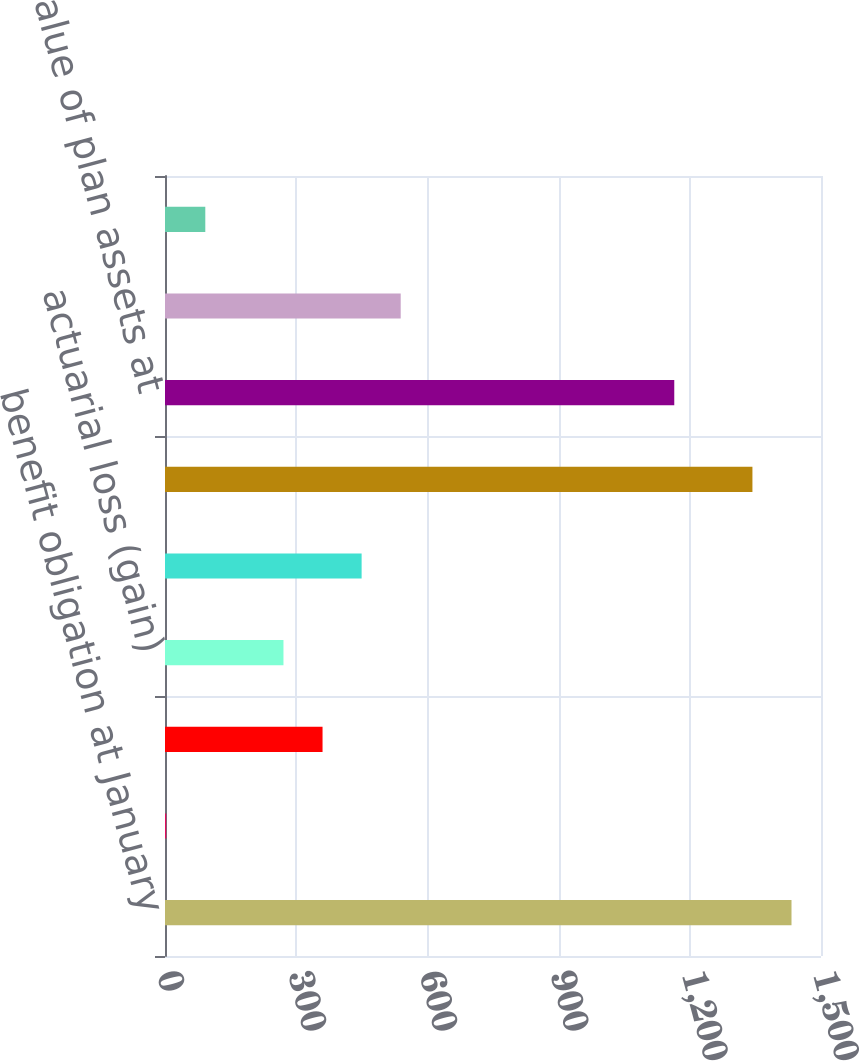Convert chart. <chart><loc_0><loc_0><loc_500><loc_500><bar_chart><fcel>benefit obligation at January<fcel>Service cost<fcel>interest cost<fcel>actuarial loss (gain)<fcel>benefits paid<fcel>benefit obligation at december<fcel>Fair value of plan assets at<fcel>actual return on plan assets<fcel>contributions<nl><fcel>1432.56<fcel>2.8<fcel>360.24<fcel>270.88<fcel>449.6<fcel>1343.2<fcel>1164.48<fcel>538.96<fcel>92.16<nl></chart> 